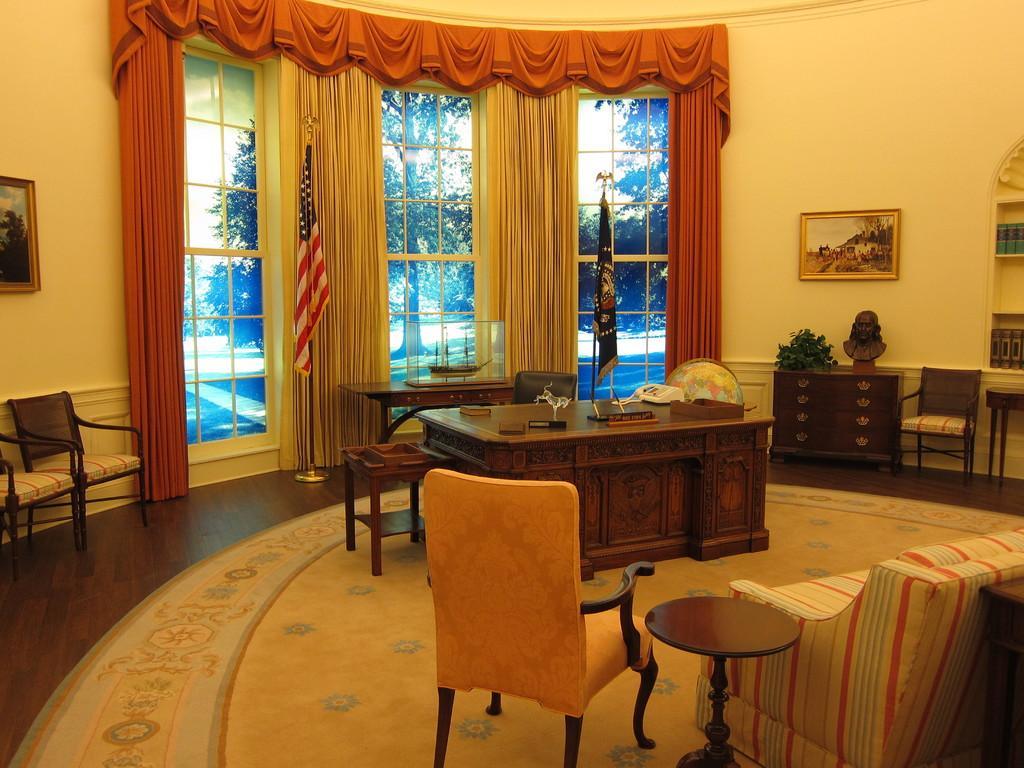How would you summarize this image in a sentence or two? This is an inside view. In the middle of the room there is a table. On the right side there is a couch and a chair. In the background I can see few curtains to the windows and also I can see few frames are attached to the wall. In the background there are some chairs and a table on which few objects are placed. 